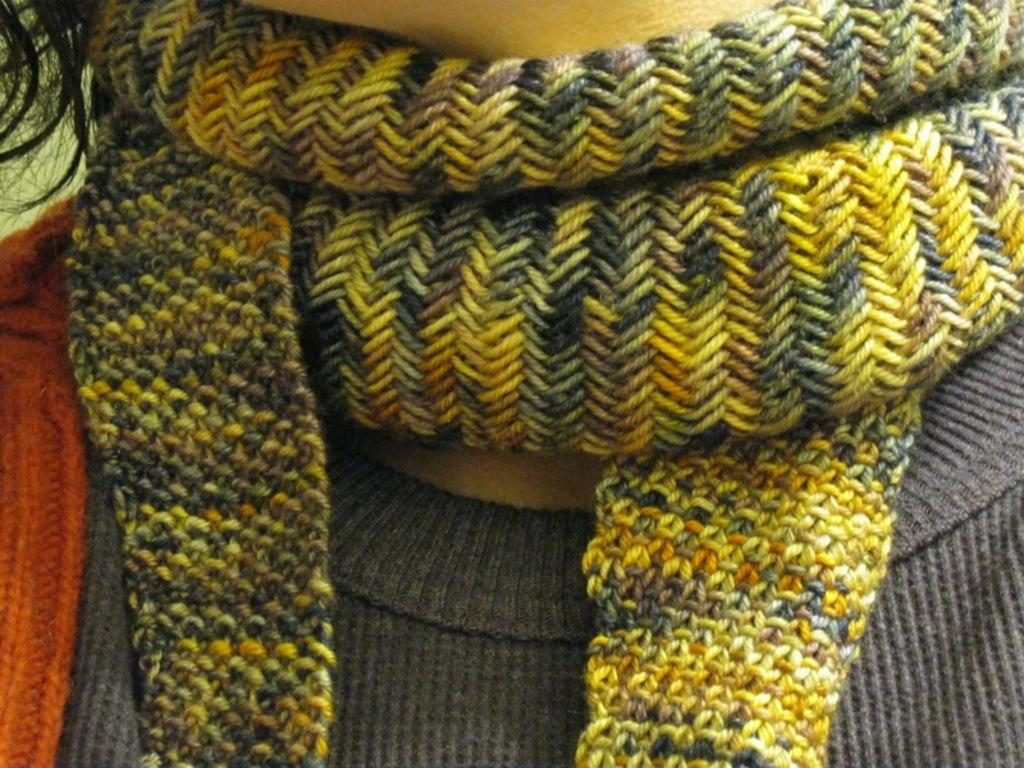Who or what is present in the image? There is a person in the image. What type of clothing is the person wearing around their neck? The person is wearing a woolen scarf. What type of clothing is the person wearing on their upper body? The person is wearing a woolen shirt. What verse is the person reciting in the image? There is no mention of a verse or any recitation in the image. 